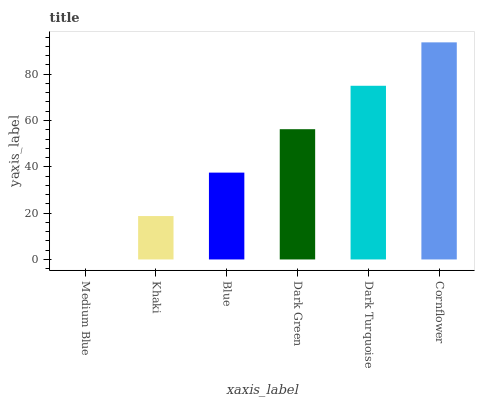Is Medium Blue the minimum?
Answer yes or no. Yes. Is Cornflower the maximum?
Answer yes or no. Yes. Is Khaki the minimum?
Answer yes or no. No. Is Khaki the maximum?
Answer yes or no. No. Is Khaki greater than Medium Blue?
Answer yes or no. Yes. Is Medium Blue less than Khaki?
Answer yes or no. Yes. Is Medium Blue greater than Khaki?
Answer yes or no. No. Is Khaki less than Medium Blue?
Answer yes or no. No. Is Dark Green the high median?
Answer yes or no. Yes. Is Blue the low median?
Answer yes or no. Yes. Is Medium Blue the high median?
Answer yes or no. No. Is Khaki the low median?
Answer yes or no. No. 